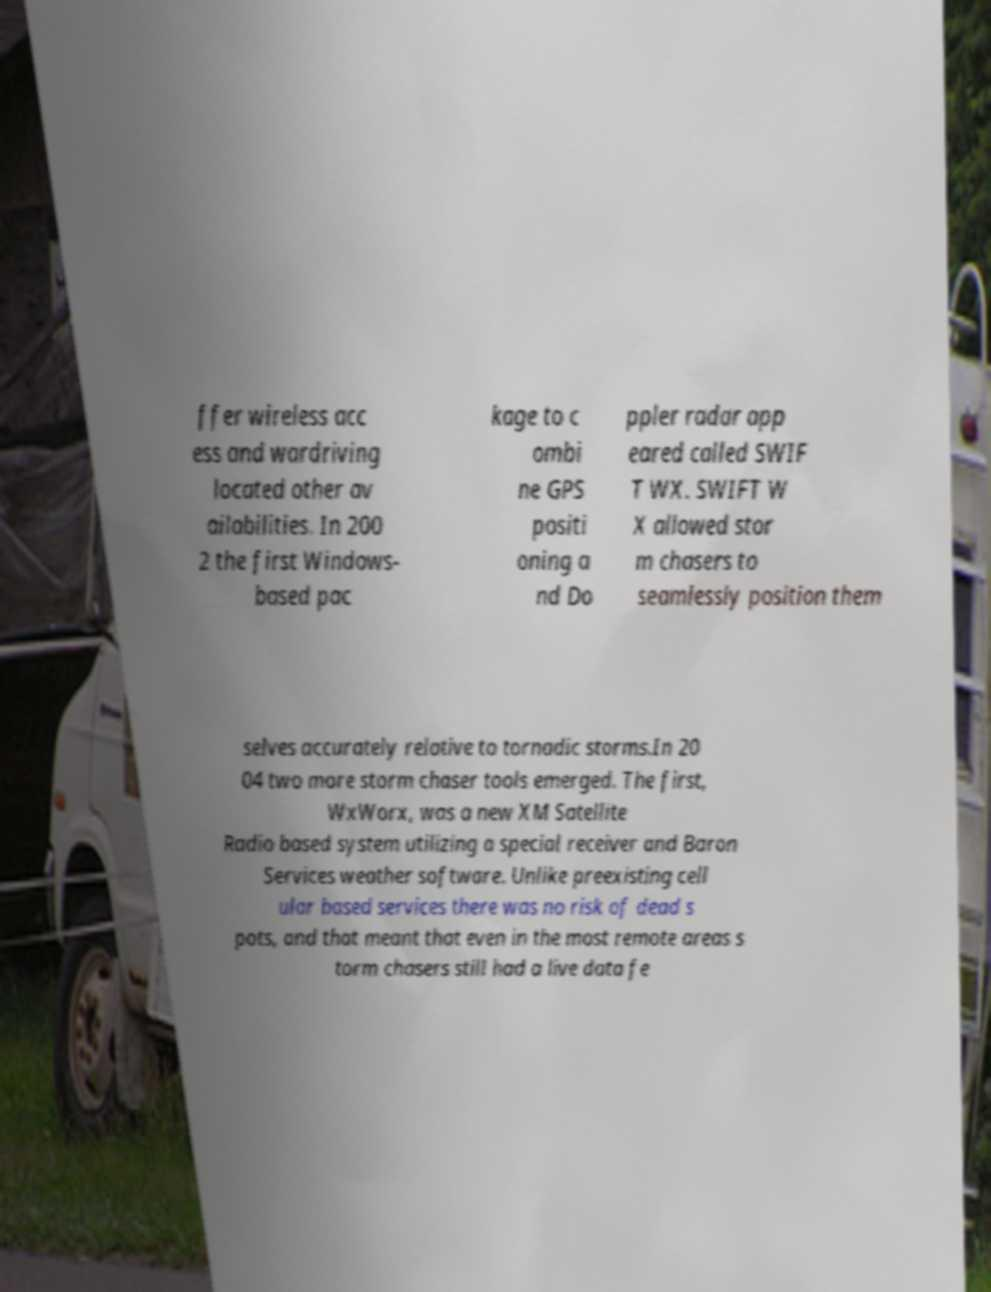For documentation purposes, I need the text within this image transcribed. Could you provide that? ffer wireless acc ess and wardriving located other av ailabilities. In 200 2 the first Windows- based pac kage to c ombi ne GPS positi oning a nd Do ppler radar app eared called SWIF T WX. SWIFT W X allowed stor m chasers to seamlessly position them selves accurately relative to tornadic storms.In 20 04 two more storm chaser tools emerged. The first, WxWorx, was a new XM Satellite Radio based system utilizing a special receiver and Baron Services weather software. Unlike preexisting cell ular based services there was no risk of dead s pots, and that meant that even in the most remote areas s torm chasers still had a live data fe 